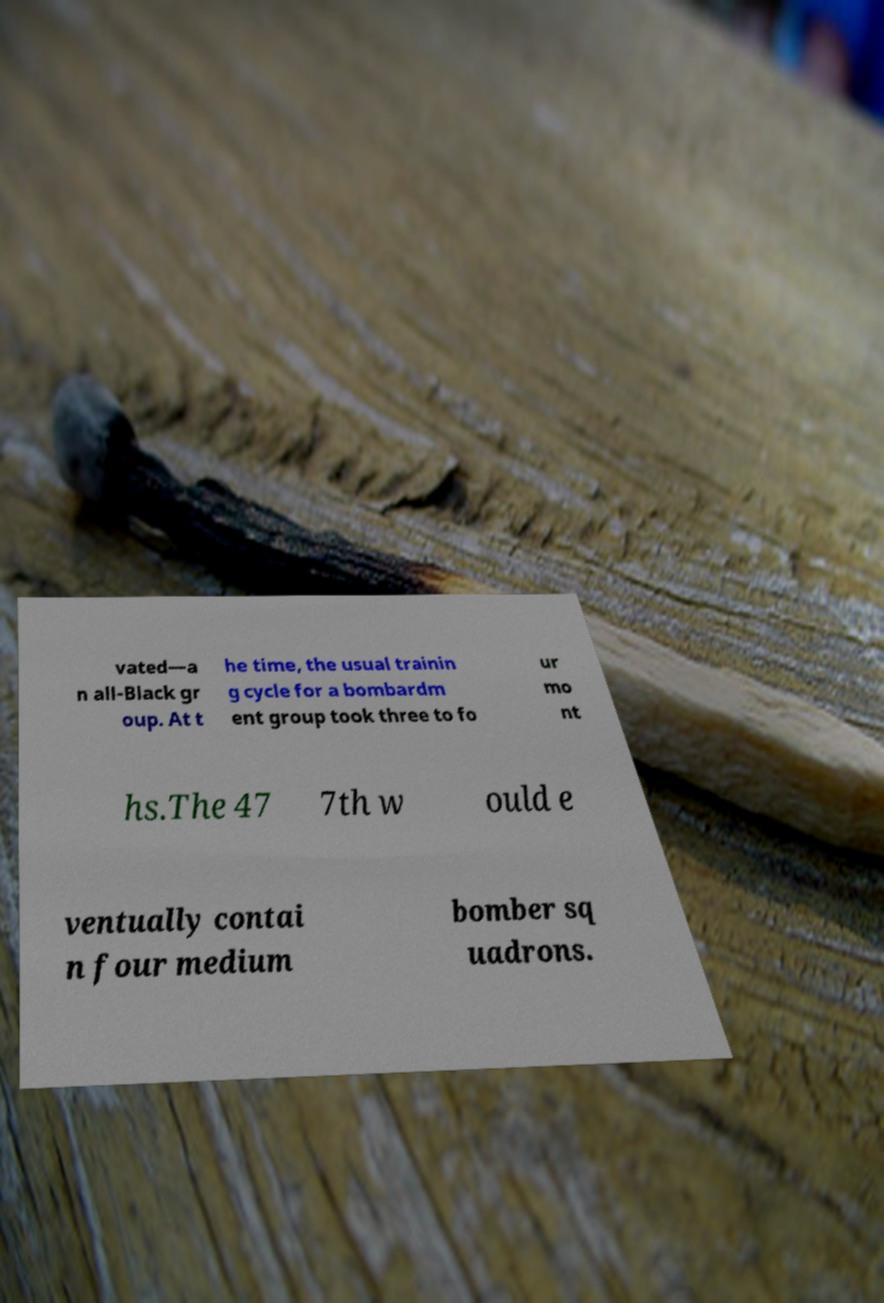Could you assist in decoding the text presented in this image and type it out clearly? vated—a n all-Black gr oup. At t he time, the usual trainin g cycle for a bombardm ent group took three to fo ur mo nt hs.The 47 7th w ould e ventually contai n four medium bomber sq uadrons. 